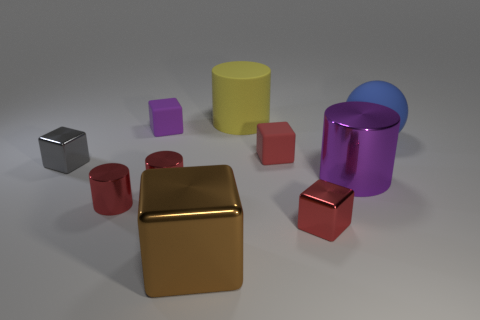Is the number of large blue spheres on the left side of the small purple rubber object the same as the number of large blue matte things that are left of the big brown shiny thing?
Provide a short and direct response. Yes. There is a tiny metal object to the right of the large shiny block; is its shape the same as the large brown object?
Offer a very short reply. Yes. Do the gray metal thing and the purple metallic thing have the same shape?
Keep it short and to the point. No. How many metallic things are balls or tiny red blocks?
Offer a terse response. 1. What material is the small block that is the same color as the large metallic cylinder?
Give a very brief answer. Rubber. Is the size of the yellow matte thing the same as the blue rubber ball?
Your response must be concise. Yes. What number of things are shiny things or small matte cubes that are on the right side of the brown shiny object?
Offer a very short reply. 7. There is a yellow cylinder that is the same size as the purple metal cylinder; what is its material?
Make the answer very short. Rubber. What is the big object that is both in front of the small purple thing and left of the big purple cylinder made of?
Make the answer very short. Metal. There is a small block behind the large matte sphere; are there any purple rubber cubes left of it?
Give a very brief answer. No. 